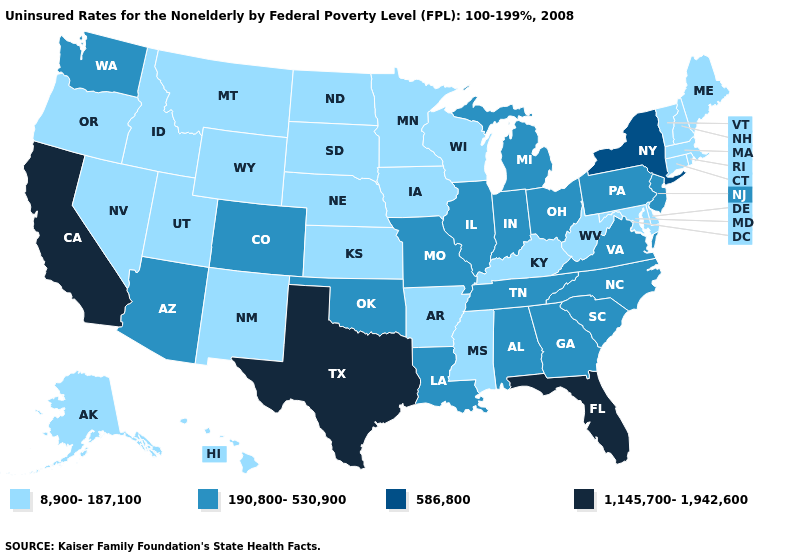Name the states that have a value in the range 8,900-187,100?
Give a very brief answer. Alaska, Arkansas, Connecticut, Delaware, Hawaii, Idaho, Iowa, Kansas, Kentucky, Maine, Maryland, Massachusetts, Minnesota, Mississippi, Montana, Nebraska, Nevada, New Hampshire, New Mexico, North Dakota, Oregon, Rhode Island, South Dakota, Utah, Vermont, West Virginia, Wisconsin, Wyoming. What is the value of Mississippi?
Concise answer only. 8,900-187,100. Does Florida have a higher value than Montana?
Concise answer only. Yes. Is the legend a continuous bar?
Give a very brief answer. No. What is the lowest value in states that border North Dakota?
Quick response, please. 8,900-187,100. What is the value of Arizona?
Answer briefly. 190,800-530,900. Does Rhode Island have the highest value in the Northeast?
Be succinct. No. What is the value of Vermont?
Be succinct. 8,900-187,100. Name the states that have a value in the range 586,800?
Concise answer only. New York. Name the states that have a value in the range 8,900-187,100?
Short answer required. Alaska, Arkansas, Connecticut, Delaware, Hawaii, Idaho, Iowa, Kansas, Kentucky, Maine, Maryland, Massachusetts, Minnesota, Mississippi, Montana, Nebraska, Nevada, New Hampshire, New Mexico, North Dakota, Oregon, Rhode Island, South Dakota, Utah, Vermont, West Virginia, Wisconsin, Wyoming. Among the states that border Iowa , which have the lowest value?
Write a very short answer. Minnesota, Nebraska, South Dakota, Wisconsin. Does Nebraska have the lowest value in the USA?
Concise answer only. Yes. Name the states that have a value in the range 8,900-187,100?
Write a very short answer. Alaska, Arkansas, Connecticut, Delaware, Hawaii, Idaho, Iowa, Kansas, Kentucky, Maine, Maryland, Massachusetts, Minnesota, Mississippi, Montana, Nebraska, Nevada, New Hampshire, New Mexico, North Dakota, Oregon, Rhode Island, South Dakota, Utah, Vermont, West Virginia, Wisconsin, Wyoming. Among the states that border Arizona , which have the highest value?
Be succinct. California. 